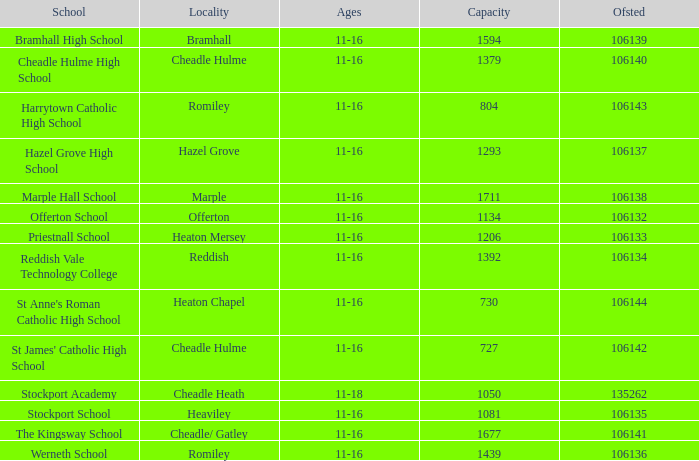Which Ofsted has a School of marple hall school, and a Capacity larger than 1711? None. 